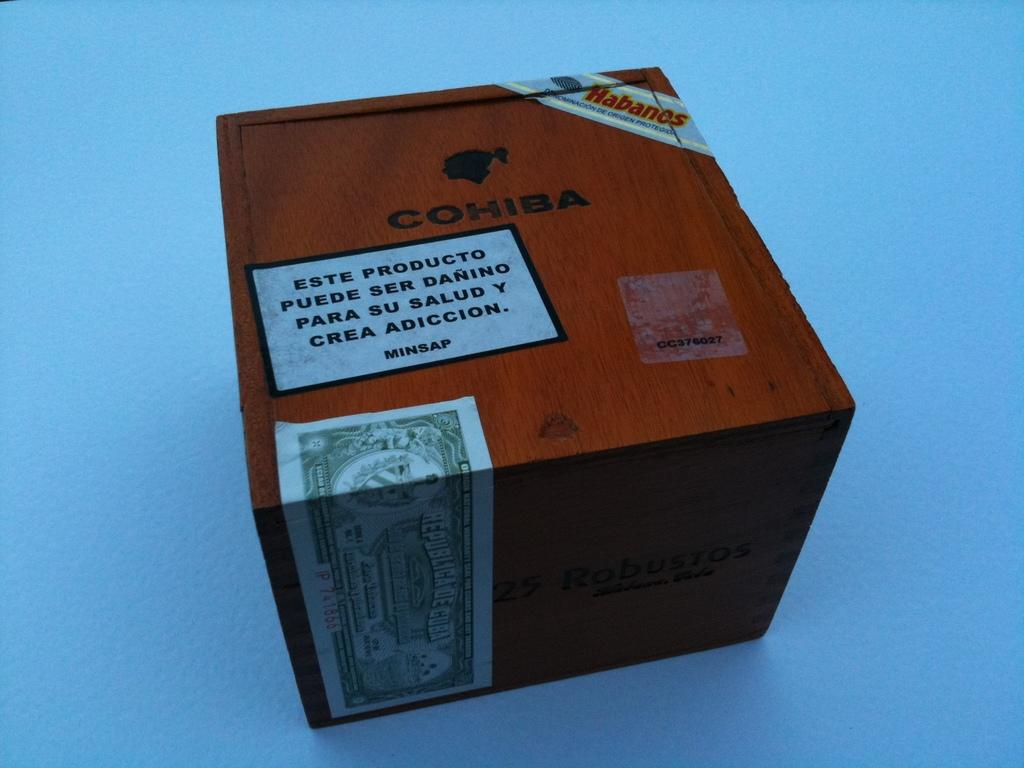Provide a one-sentence caption for the provided image. A wooden box is marked Cohiba in black lettering. 